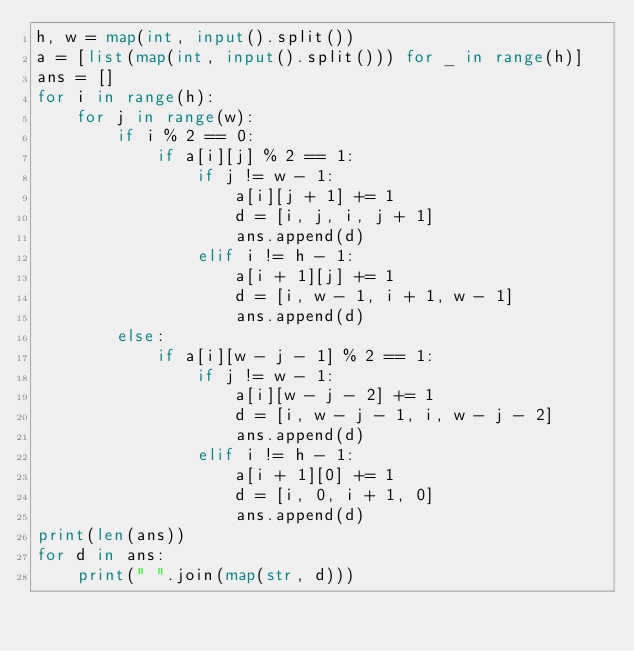<code> <loc_0><loc_0><loc_500><loc_500><_Python_>h, w = map(int, input().split())
a = [list(map(int, input().split())) for _ in range(h)]
ans = []
for i in range(h):
    for j in range(w):
        if i % 2 == 0:
            if a[i][j] % 2 == 1:
                if j != w - 1:
                    a[i][j + 1] += 1
                    d = [i, j, i, j + 1]
                    ans.append(d)
                elif i != h - 1:
                    a[i + 1][j] += 1
                    d = [i, w - 1, i + 1, w - 1]
                    ans.append(d)
        else:
            if a[i][w - j - 1] % 2 == 1:
                if j != w - 1:
                    a[i][w - j - 2] += 1
                    d = [i, w - j - 1, i, w - j - 2]
                    ans.append(d)
                elif i != h - 1:
                    a[i + 1][0] += 1
                    d = [i, 0, i + 1, 0]
                    ans.append(d)
print(len(ans))
for d in ans:
    print(" ".join(map(str, d)))</code> 